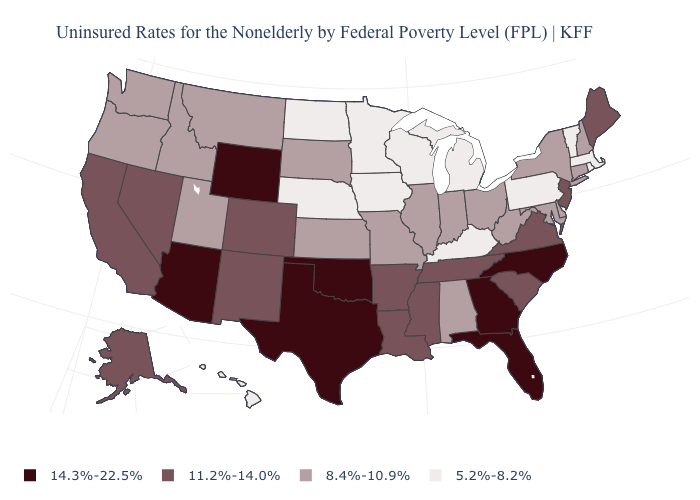Does California have the same value as Mississippi?
Quick response, please. Yes. What is the value of Utah?
Quick response, please. 8.4%-10.9%. Name the states that have a value in the range 8.4%-10.9%?
Short answer required. Alabama, Connecticut, Delaware, Idaho, Illinois, Indiana, Kansas, Maryland, Missouri, Montana, New Hampshire, New York, Ohio, Oregon, South Dakota, Utah, Washington, West Virginia. Is the legend a continuous bar?
Write a very short answer. No. What is the value of Montana?
Concise answer only. 8.4%-10.9%. What is the value of Missouri?
Answer briefly. 8.4%-10.9%. What is the value of Oklahoma?
Answer briefly. 14.3%-22.5%. Which states have the lowest value in the USA?
Give a very brief answer. Hawaii, Iowa, Kentucky, Massachusetts, Michigan, Minnesota, Nebraska, North Dakota, Pennsylvania, Rhode Island, Vermont, Wisconsin. Does North Carolina have the highest value in the USA?
Quick response, please. Yes. How many symbols are there in the legend?
Concise answer only. 4. Name the states that have a value in the range 5.2%-8.2%?
Quick response, please. Hawaii, Iowa, Kentucky, Massachusetts, Michigan, Minnesota, Nebraska, North Dakota, Pennsylvania, Rhode Island, Vermont, Wisconsin. Name the states that have a value in the range 8.4%-10.9%?
Quick response, please. Alabama, Connecticut, Delaware, Idaho, Illinois, Indiana, Kansas, Maryland, Missouri, Montana, New Hampshire, New York, Ohio, Oregon, South Dakota, Utah, Washington, West Virginia. Among the states that border North Carolina , which have the lowest value?
Write a very short answer. South Carolina, Tennessee, Virginia. Does the first symbol in the legend represent the smallest category?
Quick response, please. No. What is the lowest value in the USA?
Keep it brief. 5.2%-8.2%. 